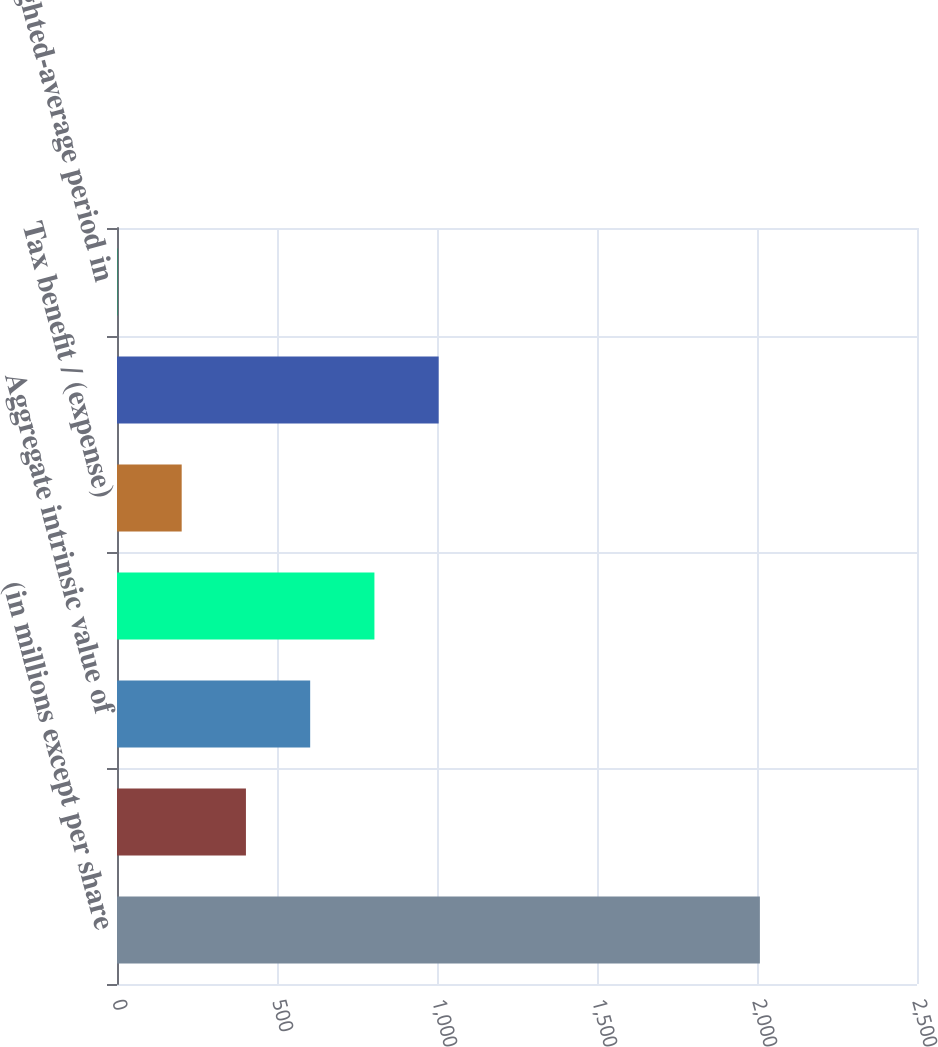Convert chart to OTSL. <chart><loc_0><loc_0><loc_500><loc_500><bar_chart><fcel>(in millions except per share<fcel>Weighted-average grant date<fcel>Aggregate intrinsic value of<fcel>Cash received upon exercise<fcel>Tax benefit / (expense)<fcel>Total compensation cost net of<fcel>Weighted-average period in<nl><fcel>2009<fcel>402.92<fcel>603.68<fcel>804.44<fcel>202.16<fcel>1005.2<fcel>1.4<nl></chart> 